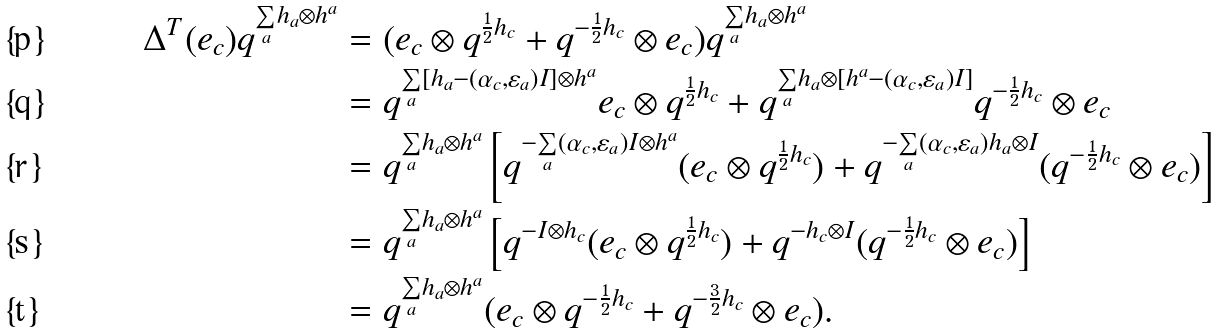<formula> <loc_0><loc_0><loc_500><loc_500>\Delta ^ { T } ( e _ { c } ) q ^ { \underset { a } { \sum } h _ { a } \otimes h ^ { a } } & = ( e _ { c } \otimes q ^ { \frac { 1 } { 2 } h _ { c } } + q ^ { - \frac { 1 } { 2 } h _ { c } } \otimes e _ { c } ) q ^ { \underset { a } { \sum } h _ { a } \otimes h ^ { a } } \\ & = q ^ { \underset { a } { \sum } [ h _ { a } - ( \alpha _ { c } , \varepsilon _ { a } ) I ] \otimes h ^ { a } } e _ { c } \otimes q ^ { \frac { 1 } { 2 } h _ { c } } + q ^ { \underset { a } { \sum } h _ { a } \otimes [ h ^ { a } - ( \alpha _ { c } , \varepsilon _ { a } ) I ] } q ^ { - \frac { 1 } { 2 } h _ { c } } \otimes e _ { c } \\ & = q ^ { \underset { a } { \sum } h _ { a } \otimes h ^ { a } } \left [ q ^ { - \underset { a } { \sum } ( \alpha _ { c } , \varepsilon _ { a } ) I \otimes h ^ { a } } ( e _ { c } \otimes q ^ { \frac { 1 } { 2 } h _ { c } } ) + q ^ { - \underset { a } { \sum } ( \alpha _ { c } , \varepsilon _ { a } ) h _ { a } \otimes I } ( q ^ { - \frac { 1 } { 2 } h _ { c } } \otimes e _ { c } ) \right ] \\ & = q ^ { \underset { a } { \sum } h _ { a } \otimes h ^ { a } } \left [ q ^ { - I \otimes h _ { c } } ( e _ { c } \otimes q ^ { \frac { 1 } { 2 } h _ { c } } ) + q ^ { - h _ { c } \otimes I } ( q ^ { - \frac { 1 } { 2 } h _ { c } } \otimes e _ { c } ) \right ] \\ & = q ^ { \underset { a } { \sum } h _ { a } \otimes h ^ { a } } ( e _ { c } \otimes q ^ { - \frac { 1 } { 2 } h _ { c } } + q ^ { - \frac { 3 } { 2 } h _ { c } } \otimes e _ { c } ) .</formula> 